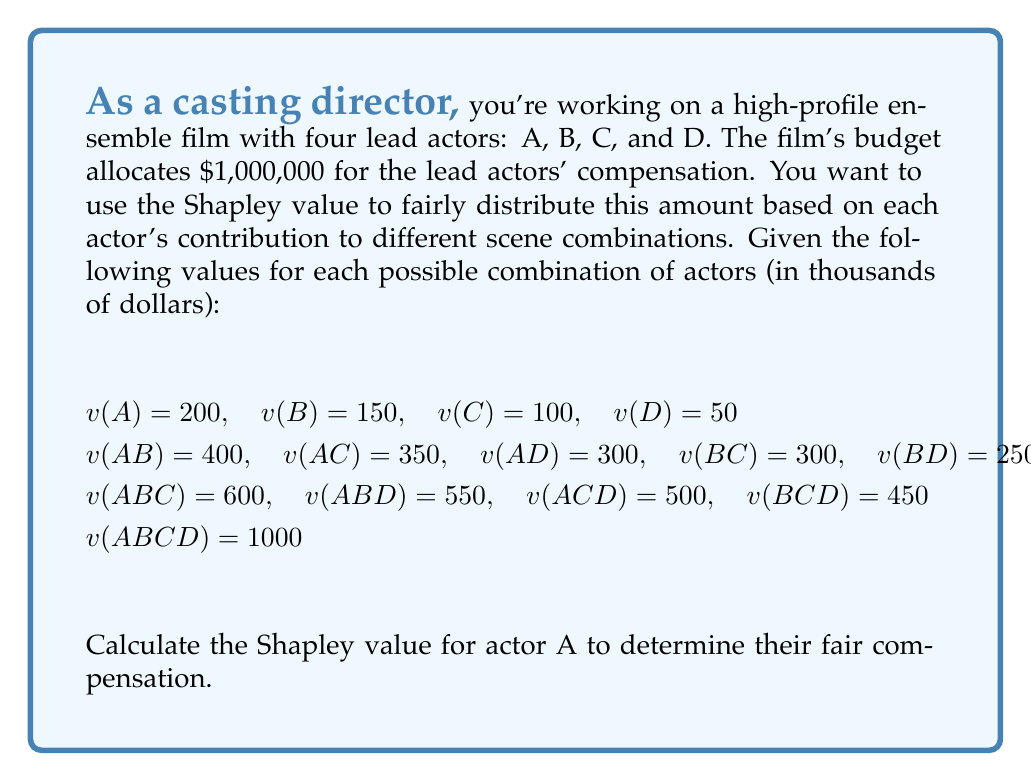Could you help me with this problem? To calculate the Shapley value for actor A, we need to consider all possible orderings of the actors and determine A's marginal contribution in each case. The formula for the Shapley value is:

$$ \phi_i(v) = \sum_{S \subseteq N \setminus \{i\}} \frac{|S|!(n-|S|-1)!}{n!}[v(S \cup \{i\}) - v(S)] $$

Where:
$\phi_i(v)$ is the Shapley value for player i
$N$ is the set of all players
$S$ is a subset of players not including i
$n$ is the total number of players
$v(S)$ is the value of coalition S

For actor A, we need to calculate:

1) A's contribution when joining alone: $v(A) - v(\emptyset) = 200 - 0 = 200$
2) A's contribution when joining one other actor:
   $(v(AB) - v(B)) + (v(AC) - v(C)) + (v(AD) - v(D))$
   $= (400 - 150) + (350 - 100) + (300 - 50) = 250 + 250 + 250 = 750$
3) A's contribution when joining two other actors:
   $(v(ABC) - v(BC)) + (v(ABD) - v(BD)) + (v(ACD) - v(CD))$
   $= (600 - 300) + (550 - 250) + (500 - 200) = 300 + 300 + 300 = 900$
4) A's contribution when joining all three other actors:
   $v(ABCD) - v(BCD) = 1000 - 450 = 550$

Now, we apply the formula:

$$ \phi_A(v) = \frac{1}{4!}(1 \cdot 200 + 3 \cdot 250 + 3 \cdot 300 + 1 \cdot 550) $$

$$ \phi_A(v) = \frac{1}{24}(200 + 750 + 900 + 550) = \frac{2400}{24} = 100 $$

Therefore, the Shapley value for actor A is $100,000.
Answer: $100,000 